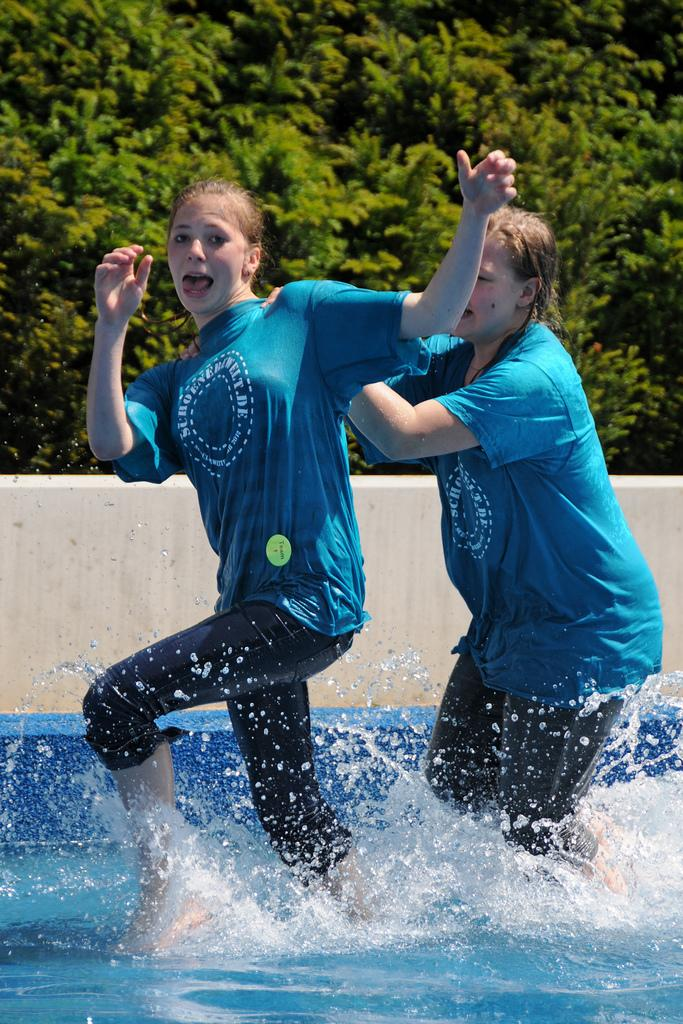Who is present in the image? There are women in the image. What are the women doing in the image? The women are walking in the water. What are the women wearing in the image? The women are wearing blue t-shirts and black trousers. What can be seen in the background of the image? There are trees and a wall visible in the image. What type of plant is the writer holding in the image? There is no writer or plant present in the image; it features women walking in the water. 